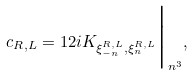<formula> <loc_0><loc_0><loc_500><loc_500>c _ { R , L } = 1 2 i K _ { \xi ^ { R , L } _ { - n } , \xi ^ { R , L } _ { n } } \Big | _ { n ^ { 3 } } ,</formula> 